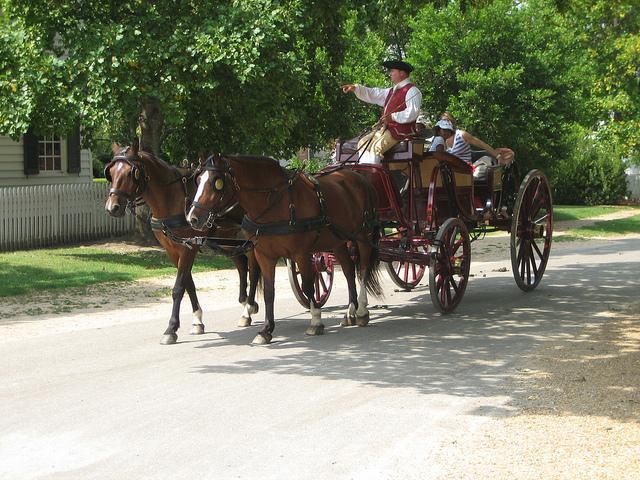How many horses are pulling the carriage?
Give a very brief answer. 2. How many horses are in the photo?
Give a very brief answer. 2. 